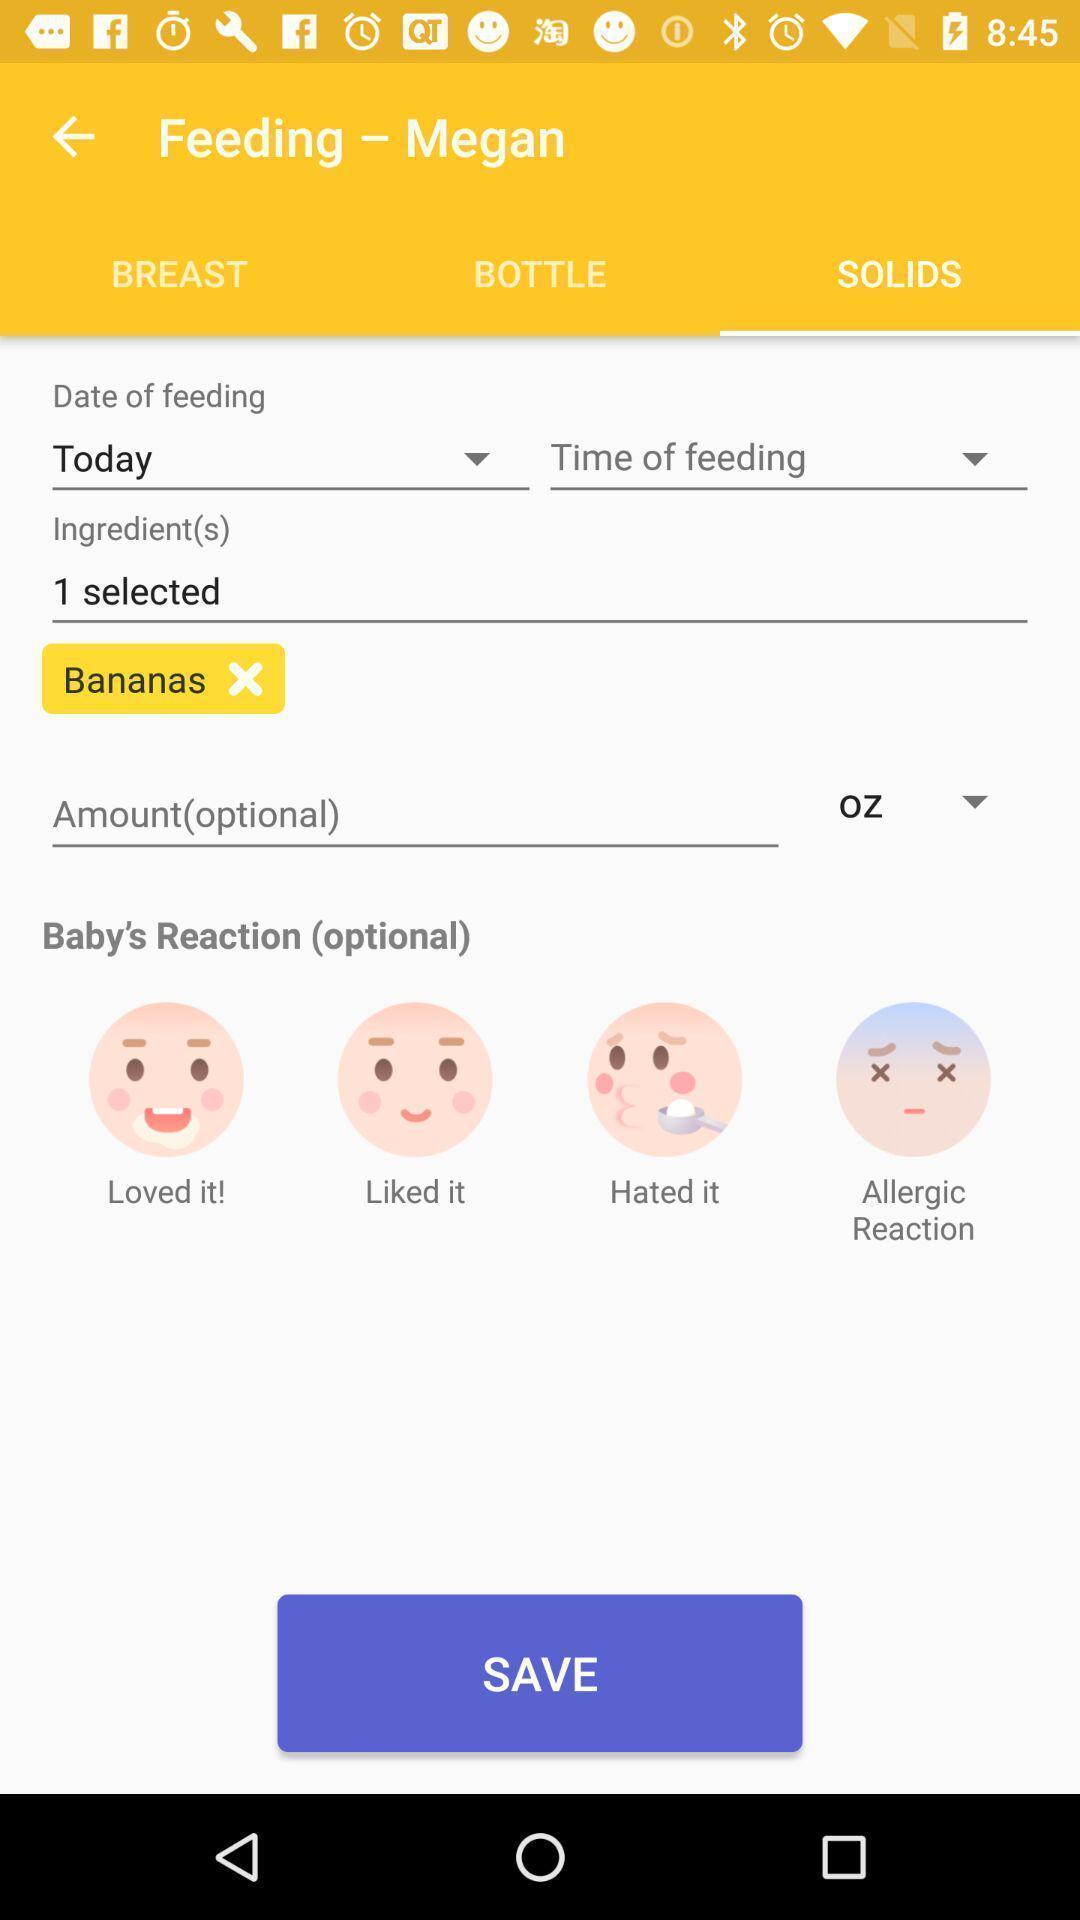What is the overall content of this screenshot? Page showing different options on an app. 